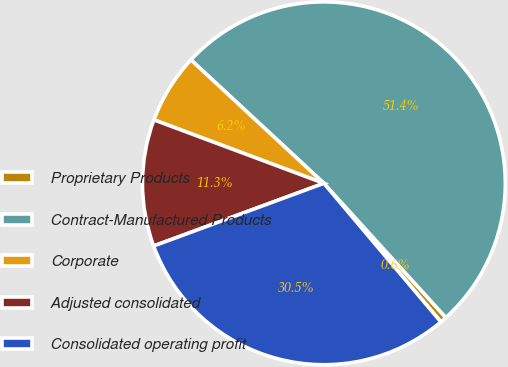<chart> <loc_0><loc_0><loc_500><loc_500><pie_chart><fcel>Proprietary Products<fcel>Contract-Manufactured Products<fcel>Corporate<fcel>Adjusted consolidated<fcel>Consolidated operating profit<nl><fcel>0.58%<fcel>51.35%<fcel>6.22%<fcel>11.3%<fcel>30.54%<nl></chart> 